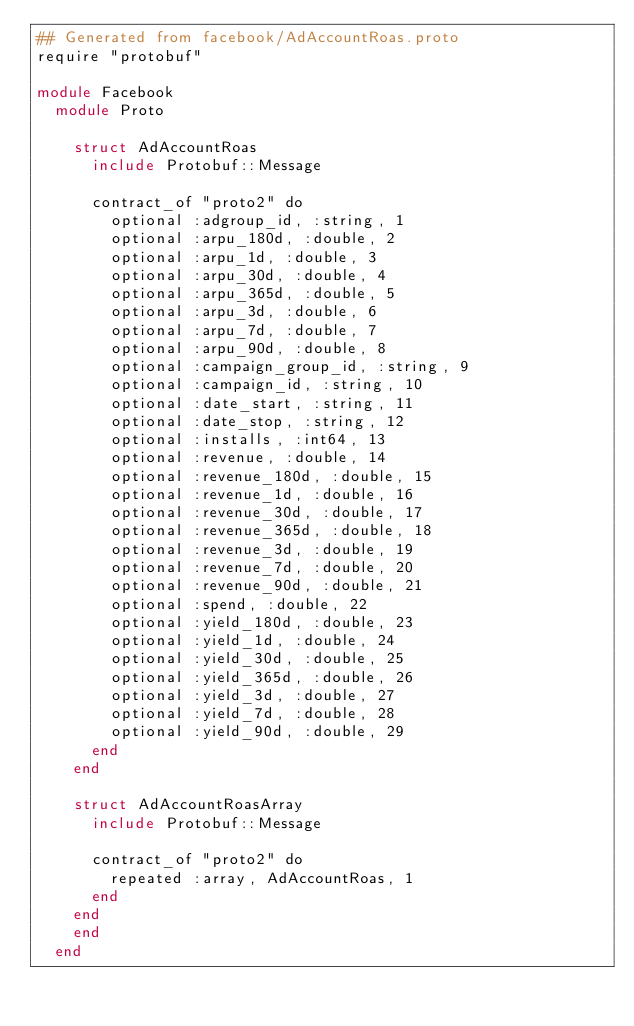<code> <loc_0><loc_0><loc_500><loc_500><_Crystal_>## Generated from facebook/AdAccountRoas.proto
require "protobuf"

module Facebook
  module Proto
    
    struct AdAccountRoas
      include Protobuf::Message
      
      contract_of "proto2" do
        optional :adgroup_id, :string, 1
        optional :arpu_180d, :double, 2
        optional :arpu_1d, :double, 3
        optional :arpu_30d, :double, 4
        optional :arpu_365d, :double, 5
        optional :arpu_3d, :double, 6
        optional :arpu_7d, :double, 7
        optional :arpu_90d, :double, 8
        optional :campaign_group_id, :string, 9
        optional :campaign_id, :string, 10
        optional :date_start, :string, 11
        optional :date_stop, :string, 12
        optional :installs, :int64, 13
        optional :revenue, :double, 14
        optional :revenue_180d, :double, 15
        optional :revenue_1d, :double, 16
        optional :revenue_30d, :double, 17
        optional :revenue_365d, :double, 18
        optional :revenue_3d, :double, 19
        optional :revenue_7d, :double, 20
        optional :revenue_90d, :double, 21
        optional :spend, :double, 22
        optional :yield_180d, :double, 23
        optional :yield_1d, :double, 24
        optional :yield_30d, :double, 25
        optional :yield_365d, :double, 26
        optional :yield_3d, :double, 27
        optional :yield_7d, :double, 28
        optional :yield_90d, :double, 29
      end
    end
    
    struct AdAccountRoasArray
      include Protobuf::Message
      
      contract_of "proto2" do
        repeated :array, AdAccountRoas, 1
      end
    end
    end
  end
</code> 